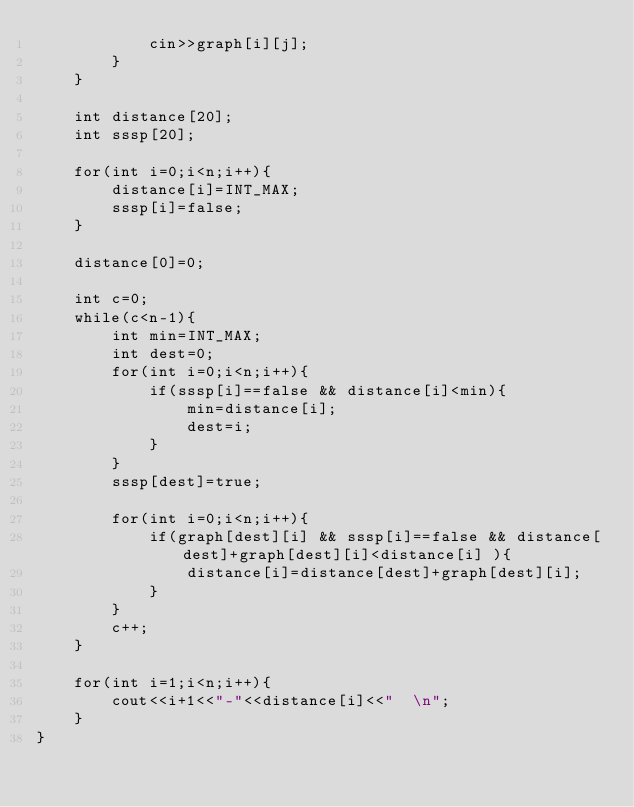Convert code to text. <code><loc_0><loc_0><loc_500><loc_500><_C++_>            cin>>graph[i][j];
        }
    }
    
    int distance[20];
    int sssp[20];

    for(int i=0;i<n;i++){
        distance[i]=INT_MAX;
        sssp[i]=false;
    }

    distance[0]=0;

    int c=0;
    while(c<n-1){
        int min=INT_MAX;
        int dest=0;
        for(int i=0;i<n;i++){
            if(sssp[i]==false && distance[i]<min){
                min=distance[i];
                dest=i;
            }
        }
        sssp[dest]=true;

        for(int i=0;i<n;i++){
            if(graph[dest][i] && sssp[i]==false && distance[dest]+graph[dest][i]<distance[i] ){
                distance[i]=distance[dest]+graph[dest][i];
            }
        }
        c++;
    }

    for(int i=1;i<n;i++){
        cout<<i+1<<"-"<<distance[i]<<"  \n";
    }
}
</code> 